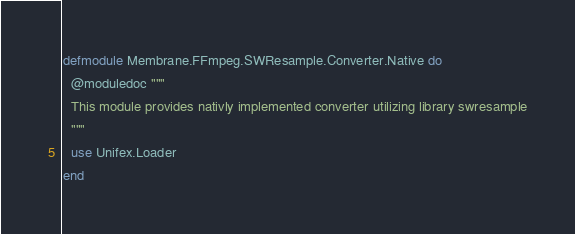Convert code to text. <code><loc_0><loc_0><loc_500><loc_500><_Elixir_>defmodule Membrane.FFmpeg.SWResample.Converter.Native do
  @moduledoc """
  This module provides nativly implemented converter utilizing library swresample
  """
  use Unifex.Loader
end
</code> 